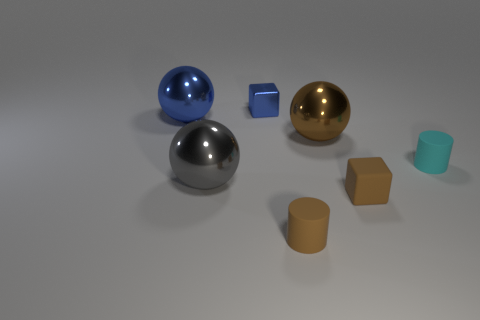Subtract all blue balls. How many balls are left? 2 Subtract all cylinders. How many objects are left? 5 Subtract 2 cylinders. How many cylinders are left? 0 Subtract all blue objects. Subtract all green spheres. How many objects are left? 5 Add 3 large gray balls. How many large gray balls are left? 4 Add 3 small red metal cylinders. How many small red metal cylinders exist? 3 Add 1 large brown metal spheres. How many objects exist? 8 Subtract all brown blocks. How many blocks are left? 1 Subtract 1 gray spheres. How many objects are left? 6 Subtract all gray cylinders. Subtract all red blocks. How many cylinders are left? 2 